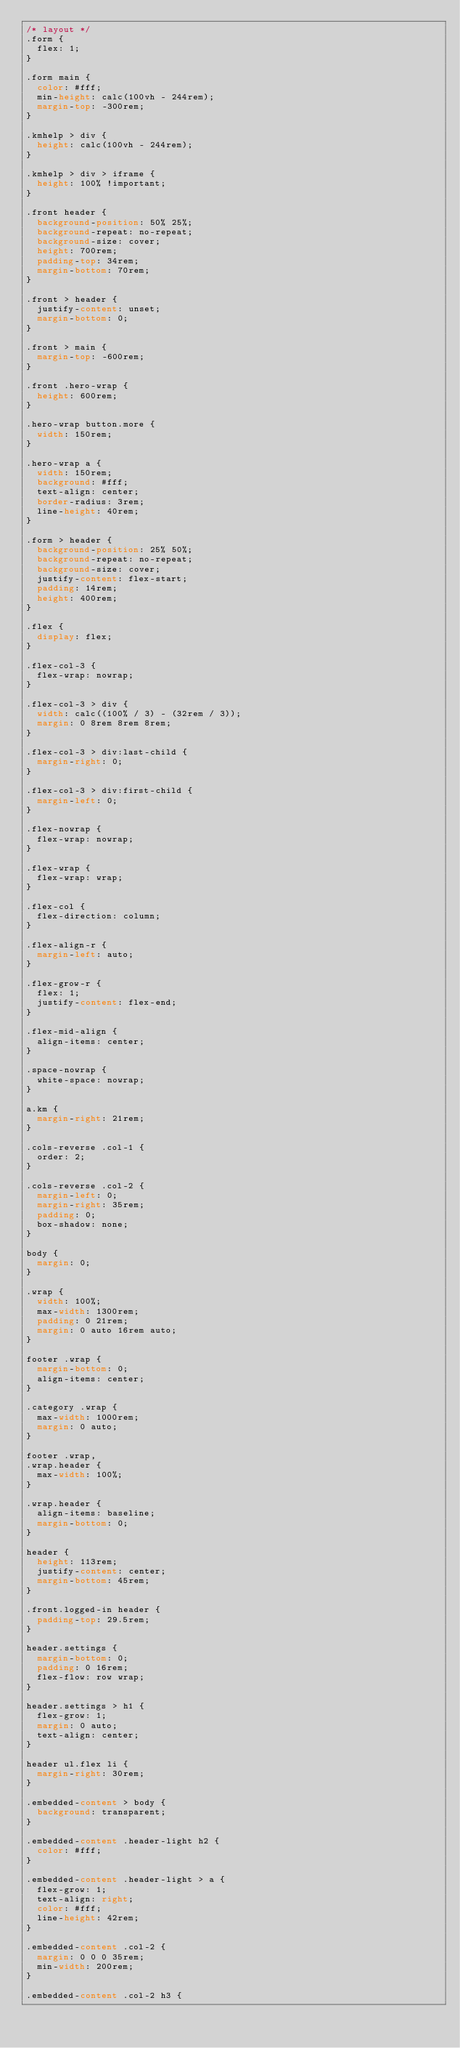<code> <loc_0><loc_0><loc_500><loc_500><_CSS_>/* layout */
.form {
  flex: 1;
}

.form main {
  color: #fff;
  min-height: calc(100vh - 244rem);
  margin-top: -300rem;
}

.kmhelp > div {
  height: calc(100vh - 244rem);
}

.kmhelp > div > iframe {
  height: 100% !important;
}

.front header {
  background-position: 50% 25%;
  background-repeat: no-repeat;
  background-size: cover;
  height: 700rem;
  padding-top: 34rem;
  margin-bottom: 70rem;
}

.front > header {
  justify-content: unset;
  margin-bottom: 0;
}

.front > main {
  margin-top: -600rem;
}

.front .hero-wrap {
  height: 600rem;
}

.hero-wrap button.more {
  width: 150rem;
}

.hero-wrap a {
  width: 150rem;
  background: #fff;
  text-align: center;
  border-radius: 3rem;
  line-height: 40rem;
}

.form > header {
  background-position: 25% 50%;
  background-repeat: no-repeat;
  background-size: cover;
  justify-content: flex-start;
  padding: 14rem;
  height: 400rem;
}

.flex {
  display: flex;
}

.flex-col-3 {
  flex-wrap: nowrap;
}

.flex-col-3 > div {
  width: calc((100% / 3) - (32rem / 3));
  margin: 0 8rem 8rem 8rem;
}

.flex-col-3 > div:last-child {
  margin-right: 0;
}

.flex-col-3 > div:first-child {
  margin-left: 0;
}

.flex-nowrap {
  flex-wrap: nowrap;
}

.flex-wrap {
  flex-wrap: wrap;
}

.flex-col {
  flex-direction: column;
}

.flex-align-r {
  margin-left: auto;
}

.flex-grow-r {
  flex: 1;
  justify-content: flex-end;
}

.flex-mid-align {
  align-items: center;
}

.space-nowrap {
  white-space: nowrap;
}

a.km {
  margin-right: 21rem;
}

.cols-reverse .col-1 {
  order: 2;
}

.cols-reverse .col-2 {
  margin-left: 0;
  margin-right: 35rem;
  padding: 0;
  box-shadow: none;
}

body {
  margin: 0;
}

.wrap {
  width: 100%;
  max-width: 1300rem;
  padding: 0 21rem;
  margin: 0 auto 16rem auto;
}

footer .wrap {
  margin-bottom: 0;
  align-items: center;
}

.category .wrap {
  max-width: 1000rem;
  margin: 0 auto;
}

footer .wrap,
.wrap.header {
  max-width: 100%;
}

.wrap.header {
  align-items: baseline;
  margin-bottom: 0;
}

header {
  height: 113rem;
  justify-content: center;
  margin-bottom: 45rem;
}

.front.logged-in header {
  padding-top: 29.5rem;
}

header.settings {
  margin-bottom: 0;
  padding: 0 16rem;
  flex-flow: row wrap;
}

header.settings > h1 {
  flex-grow: 1;
  margin: 0 auto;
  text-align: center;
}

header ul.flex li {
  margin-right: 30rem;
}

.embedded-content > body {
  background: transparent;
}

.embedded-content .header-light h2 {
  color: #fff;
}

.embedded-content .header-light > a {
  flex-grow: 1;
  text-align: right;
  color: #fff;
  line-height: 42rem;
}

.embedded-content .col-2 {
  margin: 0 0 0 35rem;
  min-width: 200rem;
}

.embedded-content .col-2 h3 {</code> 